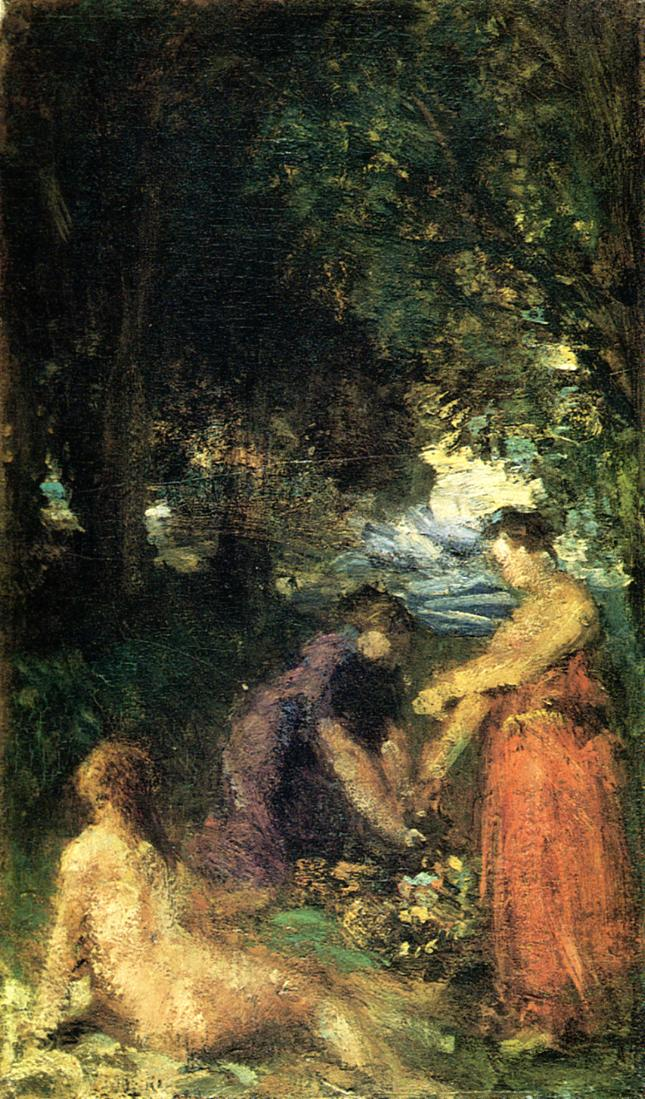Imagine you are one of the figures in this painting. Describe your thoughts and feelings as you partake in this scene. As I kneel among the soft grass, surrounded by the whispering leaves and the musky scent of the forest floor, I feel an overwhelming sense of peace. The cool earth beneath my fingers grounds me, while the distant chatter of my companions fills the air with warmth and camaraderie. The dance of sunlight through the canopy bathes us in a gentle glow, creating fleeting patterns that play across our faces. Lost in this rhythmic task, where every flower picked is a shared joy, I feel a deep connection not only to the nature cradling us but also to the timeless bond of human friendship and collaboration. Time seems to slow, and the outside world fades away, leaving only the present moment of serene unity and simple, unspoken satisfaction. Let your imagination run wild. Could this painting depict a group of forest spirits or nymphs engaging in a mystical ritual? Describe what might be happening. Indeed, in a flight of imagination, this painting could depict a gathering of forest spirits or nymphs deep within an ancient, enchanted grove. The air is thick with magic, and the low hum of their ethereal songs harmonizes with the rustling leaves, casting an enchanting spell over the scene. Each flower they gather holds a fragment of the forest's essence, a vessel for the ancient energies that sustain their mystical world. As they arrange these blooms into intricate patterns, they whisper incantations that strengthen the bonds between nature and the spirit realm. The figure reclining in the foreground is perhaps their queen, overseeing the ritual with a serene, knowing smile, as luminous tendrils of energy weave through the trees, binding the forest in a protective embrace. This enchanted moment is hidden from mortal eyes, a glimpse into a world where nature and magic dance eternally. 